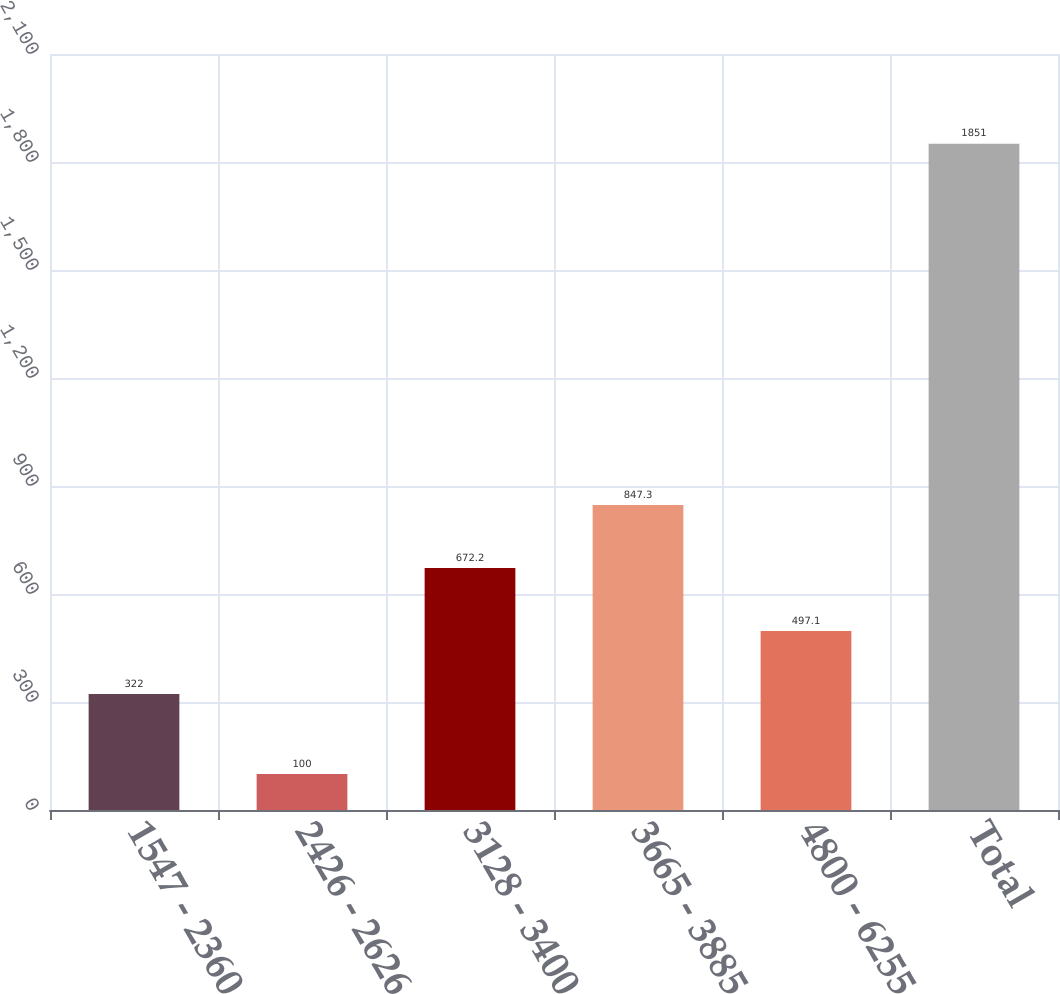Convert chart. <chart><loc_0><loc_0><loc_500><loc_500><bar_chart><fcel>1547 - 2360<fcel>2426 - 2626<fcel>3128 - 3400<fcel>3665 - 3885<fcel>4800 - 6255<fcel>Total<nl><fcel>322<fcel>100<fcel>672.2<fcel>847.3<fcel>497.1<fcel>1851<nl></chart> 